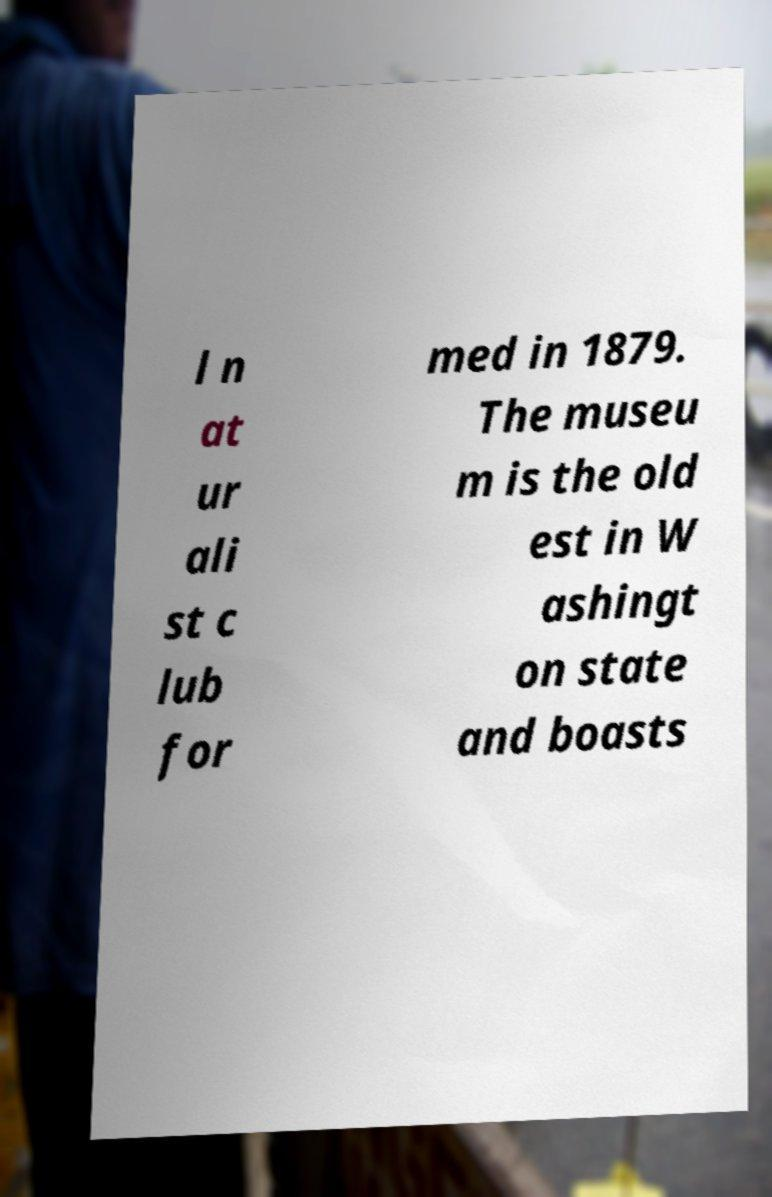Can you accurately transcribe the text from the provided image for me? l n at ur ali st c lub for med in 1879. The museu m is the old est in W ashingt on state and boasts 